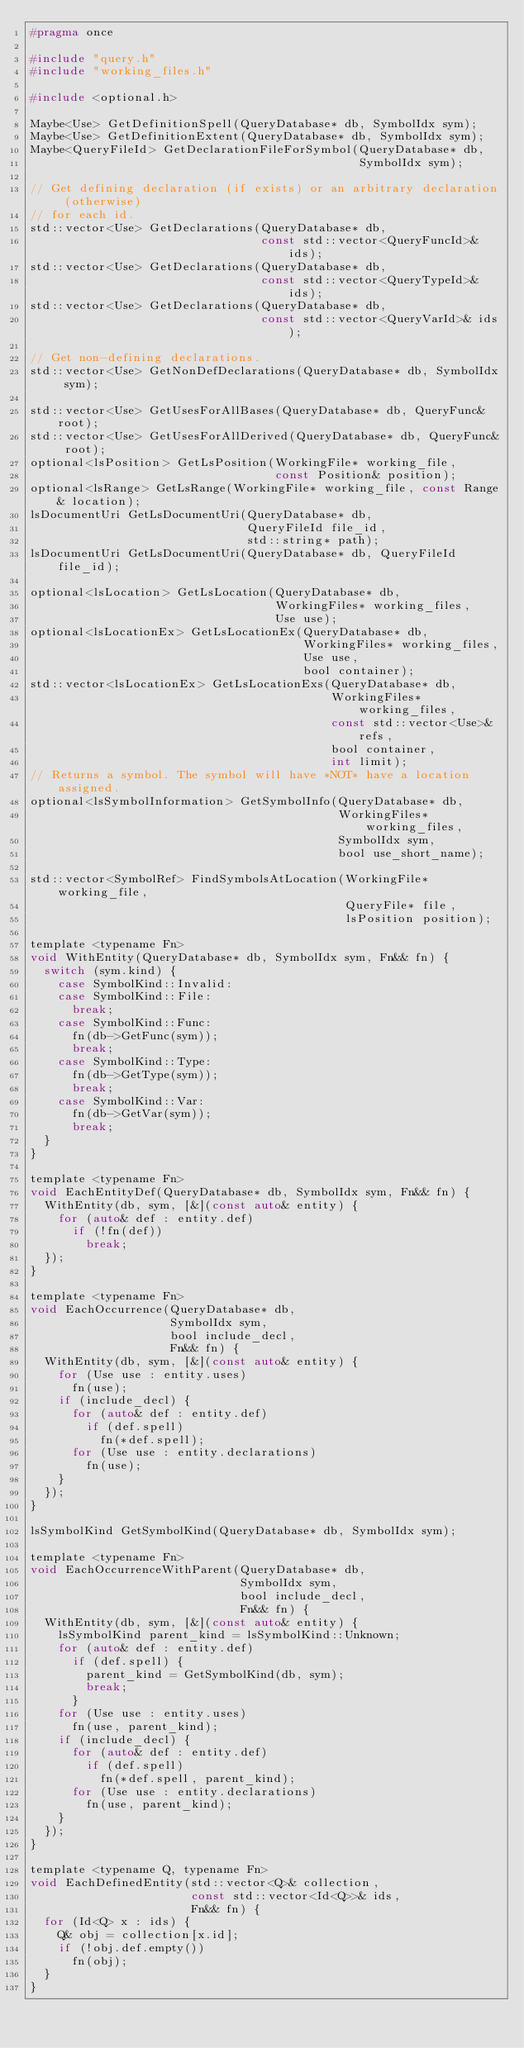<code> <loc_0><loc_0><loc_500><loc_500><_C_>#pragma once

#include "query.h"
#include "working_files.h"

#include <optional.h>

Maybe<Use> GetDefinitionSpell(QueryDatabase* db, SymbolIdx sym);
Maybe<Use> GetDefinitionExtent(QueryDatabase* db, SymbolIdx sym);
Maybe<QueryFileId> GetDeclarationFileForSymbol(QueryDatabase* db,
                                               SymbolIdx sym);

// Get defining declaration (if exists) or an arbitrary declaration (otherwise)
// for each id.
std::vector<Use> GetDeclarations(QueryDatabase* db,
                                 const std::vector<QueryFuncId>& ids);
std::vector<Use> GetDeclarations(QueryDatabase* db,
                                 const std::vector<QueryTypeId>& ids);
std::vector<Use> GetDeclarations(QueryDatabase* db,
                                 const std::vector<QueryVarId>& ids);

// Get non-defining declarations.
std::vector<Use> GetNonDefDeclarations(QueryDatabase* db, SymbolIdx sym);

std::vector<Use> GetUsesForAllBases(QueryDatabase* db, QueryFunc& root);
std::vector<Use> GetUsesForAllDerived(QueryDatabase* db, QueryFunc& root);
optional<lsPosition> GetLsPosition(WorkingFile* working_file,
                                   const Position& position);
optional<lsRange> GetLsRange(WorkingFile* working_file, const Range& location);
lsDocumentUri GetLsDocumentUri(QueryDatabase* db,
                               QueryFileId file_id,
                               std::string* path);
lsDocumentUri GetLsDocumentUri(QueryDatabase* db, QueryFileId file_id);

optional<lsLocation> GetLsLocation(QueryDatabase* db,
                                   WorkingFiles* working_files,
                                   Use use);
optional<lsLocationEx> GetLsLocationEx(QueryDatabase* db,
                                       WorkingFiles* working_files,
                                       Use use,
                                       bool container);
std::vector<lsLocationEx> GetLsLocationExs(QueryDatabase* db,
                                           WorkingFiles* working_files,
                                           const std::vector<Use>& refs,
                                           bool container,
                                           int limit);
// Returns a symbol. The symbol will have *NOT* have a location assigned.
optional<lsSymbolInformation> GetSymbolInfo(QueryDatabase* db,
                                            WorkingFiles* working_files,
                                            SymbolIdx sym,
                                            bool use_short_name);

std::vector<SymbolRef> FindSymbolsAtLocation(WorkingFile* working_file,
                                             QueryFile* file,
                                             lsPosition position);

template <typename Fn>
void WithEntity(QueryDatabase* db, SymbolIdx sym, Fn&& fn) {
  switch (sym.kind) {
    case SymbolKind::Invalid:
    case SymbolKind::File:
      break;
    case SymbolKind::Func:
      fn(db->GetFunc(sym));
      break;
    case SymbolKind::Type:
      fn(db->GetType(sym));
      break;
    case SymbolKind::Var:
      fn(db->GetVar(sym));
      break;
  }
}

template <typename Fn>
void EachEntityDef(QueryDatabase* db, SymbolIdx sym, Fn&& fn) {
  WithEntity(db, sym, [&](const auto& entity) {
    for (auto& def : entity.def)
      if (!fn(def))
        break;
  });
}

template <typename Fn>
void EachOccurrence(QueryDatabase* db,
                    SymbolIdx sym,
                    bool include_decl,
                    Fn&& fn) {
  WithEntity(db, sym, [&](const auto& entity) {
    for (Use use : entity.uses)
      fn(use);
    if (include_decl) {
      for (auto& def : entity.def)
        if (def.spell)
          fn(*def.spell);
      for (Use use : entity.declarations)
        fn(use);
    }
  });
}

lsSymbolKind GetSymbolKind(QueryDatabase* db, SymbolIdx sym);

template <typename Fn>
void EachOccurrenceWithParent(QueryDatabase* db,
                              SymbolIdx sym,
                              bool include_decl,
                              Fn&& fn) {
  WithEntity(db, sym, [&](const auto& entity) {
    lsSymbolKind parent_kind = lsSymbolKind::Unknown;
    for (auto& def : entity.def)
      if (def.spell) {
        parent_kind = GetSymbolKind(db, sym);
        break;
      }
    for (Use use : entity.uses)
      fn(use, parent_kind);
    if (include_decl) {
      for (auto& def : entity.def)
        if (def.spell)
          fn(*def.spell, parent_kind);
      for (Use use : entity.declarations)
        fn(use, parent_kind);
    }
  });
}

template <typename Q, typename Fn>
void EachDefinedEntity(std::vector<Q>& collection,
                       const std::vector<Id<Q>>& ids,
                       Fn&& fn) {
  for (Id<Q> x : ids) {
    Q& obj = collection[x.id];
    if (!obj.def.empty())
      fn(obj);
  }
}
</code> 